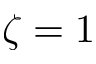Convert formula to latex. <formula><loc_0><loc_0><loc_500><loc_500>\zeta = 1</formula> 